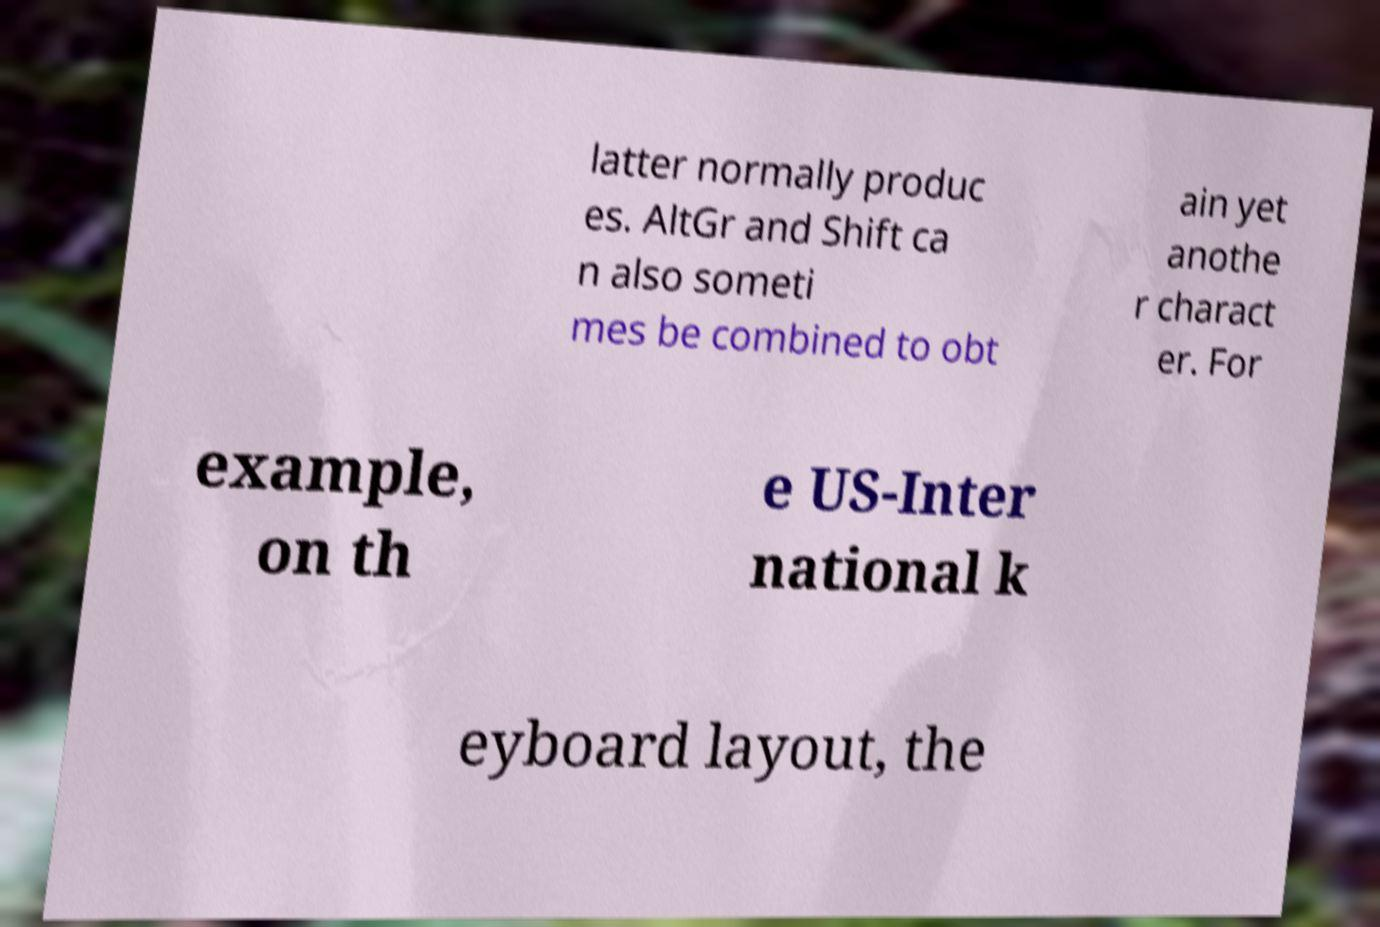For documentation purposes, I need the text within this image transcribed. Could you provide that? latter normally produc es. AltGr and Shift ca n also someti mes be combined to obt ain yet anothe r charact er. For example, on th e US-Inter national k eyboard layout, the 